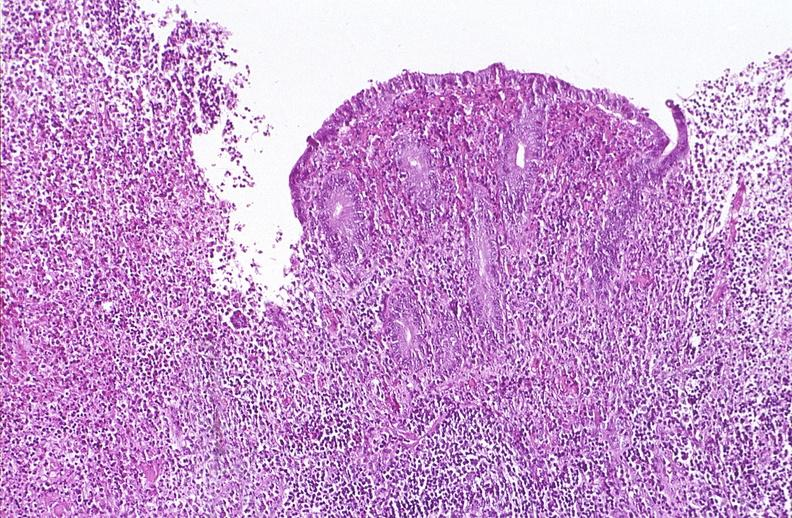s gastrointestinal present?
Answer the question using a single word or phrase. Yes 